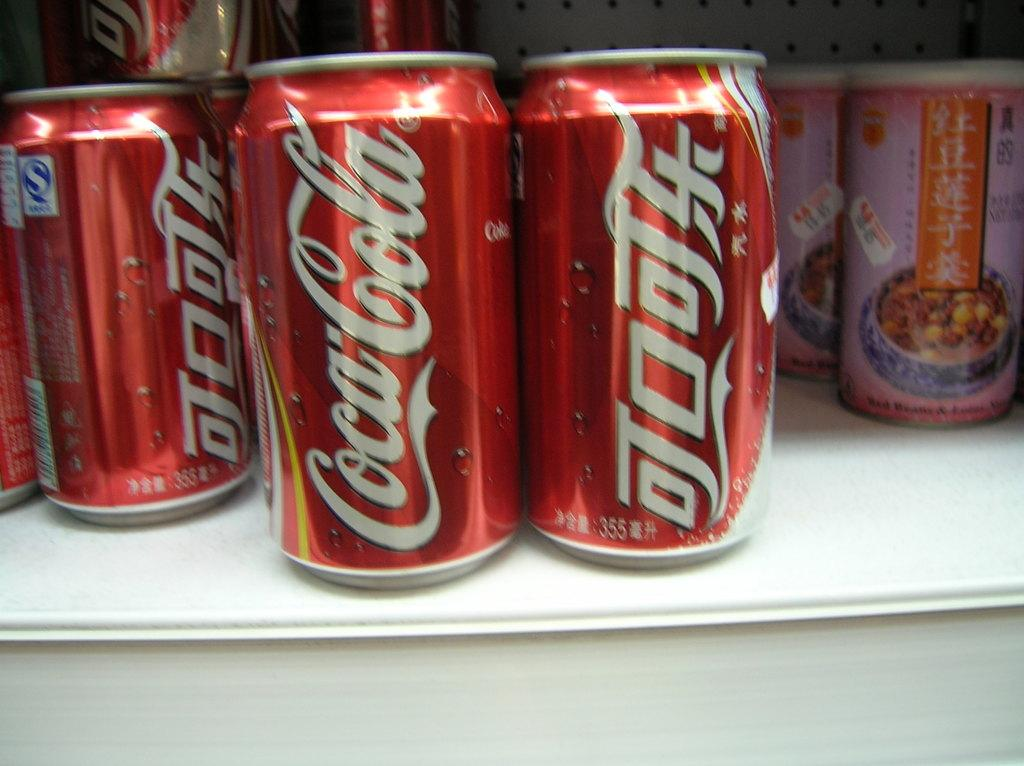<image>
Relay a brief, clear account of the picture shown. Coca cola cans near chinese food on a shelf 